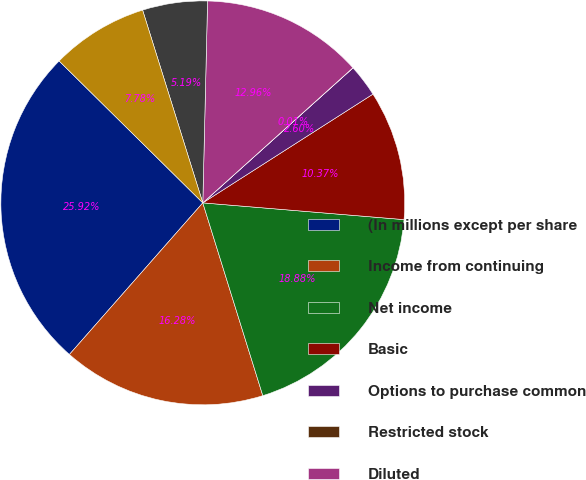<chart> <loc_0><loc_0><loc_500><loc_500><pie_chart><fcel>(In millions except per share<fcel>Income from continuing<fcel>Net income<fcel>Basic<fcel>Options to purchase common<fcel>Restricted stock<fcel>Diluted<fcel>Continuing operations<fcel>Total<nl><fcel>25.91%<fcel>16.28%<fcel>18.87%<fcel>10.37%<fcel>2.6%<fcel>0.01%<fcel>12.96%<fcel>5.19%<fcel>7.78%<nl></chart> 